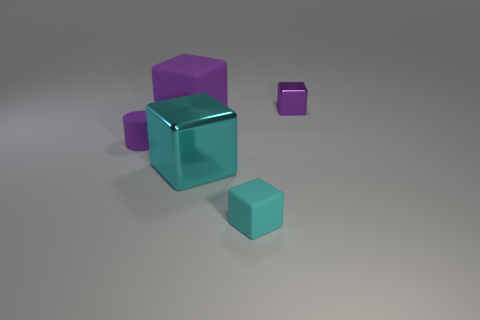What number of objects are either purple matte objects or tiny purple objects in front of the big purple object?
Make the answer very short. 2. What material is the object that is on the left side of the big metallic thing and behind the purple cylinder?
Provide a short and direct response. Rubber. Is there anything else that has the same shape as the big matte thing?
Ensure brevity in your answer.  Yes. There is another block that is made of the same material as the small cyan cube; what color is it?
Your response must be concise. Purple. What number of things are metal objects or small matte cylinders?
Your answer should be very brief. 3. Is the size of the purple cylinder the same as the purple block that is on the left side of the tiny matte cube?
Your response must be concise. No. What is the color of the tiny rubber object on the left side of the cyan block to the left of the cyan block in front of the large cyan shiny object?
Provide a short and direct response. Purple. What is the color of the tiny shiny cube?
Keep it short and to the point. Purple. Are there more objects in front of the purple matte cylinder than tiny rubber blocks that are in front of the small metallic thing?
Keep it short and to the point. Yes. There is a small cyan rubber object; is its shape the same as the purple object in front of the large purple cube?
Give a very brief answer. No. 